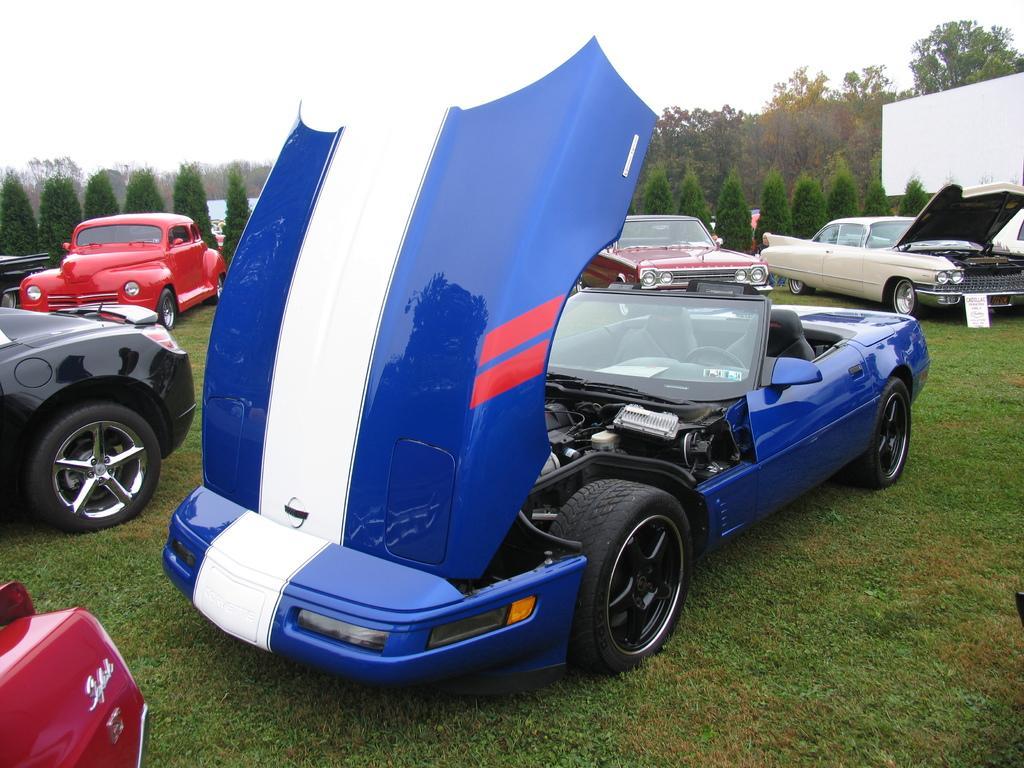Describe this image in one or two sentences. Here in this picture we can see number of cars present on the ground, which is fully covered with grass and we can see some bonnets of cars are opened and behind that we can see plants and trees present all over there and we can see the sky is cloudy. 